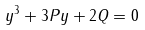<formula> <loc_0><loc_0><loc_500><loc_500>y ^ { 3 } + 3 P y + 2 Q = 0</formula> 